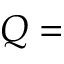<formula> <loc_0><loc_0><loc_500><loc_500>Q =</formula> 